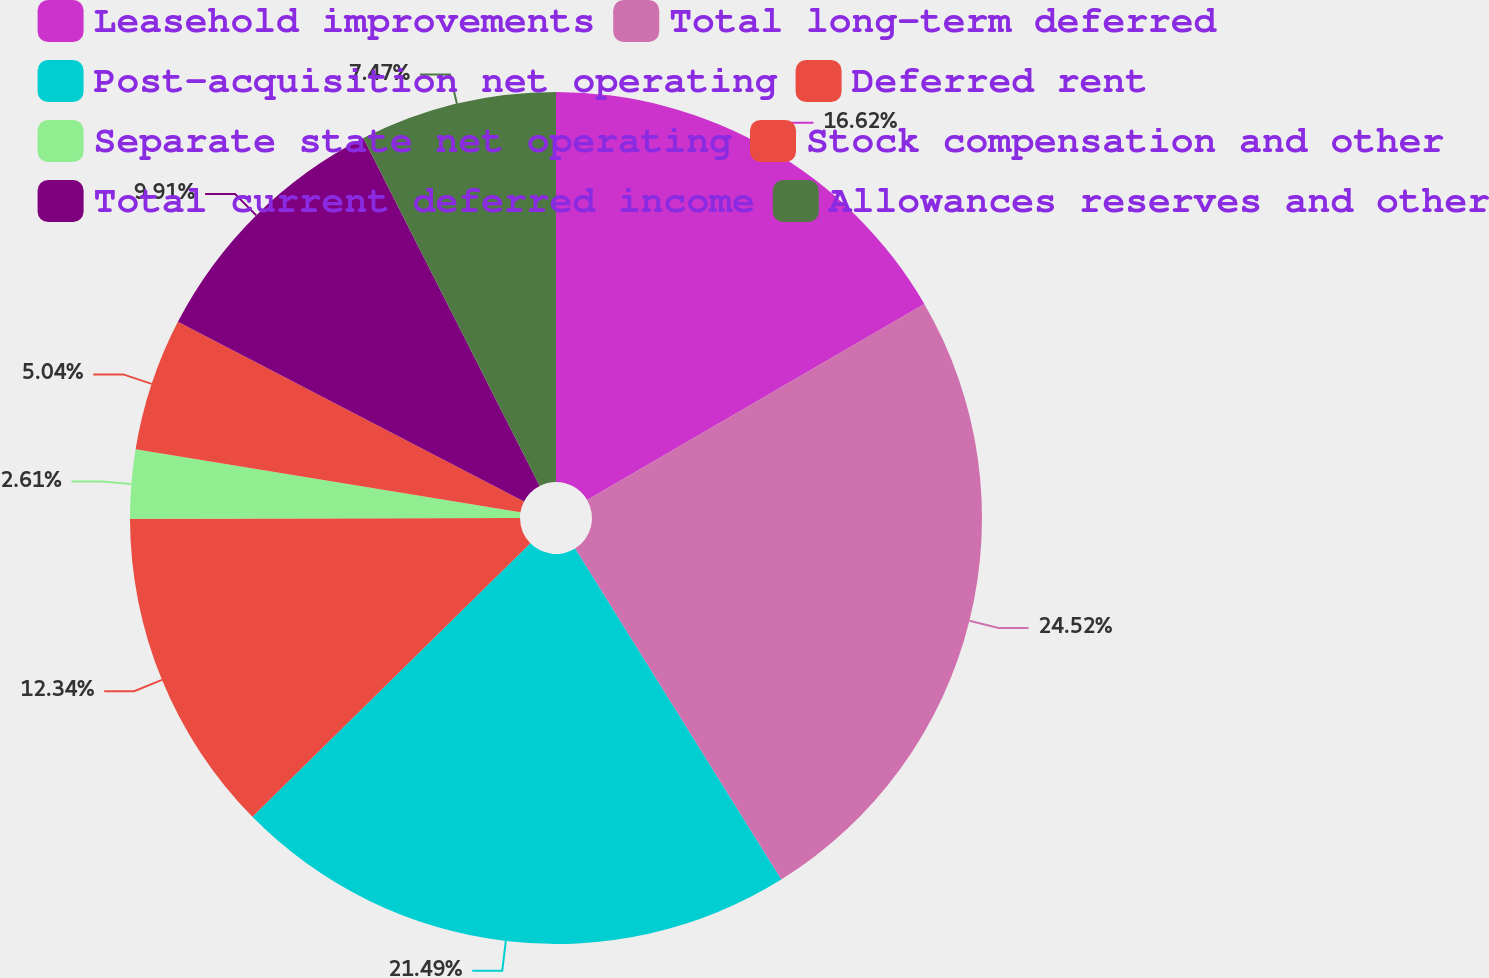Convert chart. <chart><loc_0><loc_0><loc_500><loc_500><pie_chart><fcel>Leasehold improvements<fcel>Total long-term deferred<fcel>Post-acquisition net operating<fcel>Deferred rent<fcel>Separate state net operating<fcel>Stock compensation and other<fcel>Total current deferred income<fcel>Allowances reserves and other<nl><fcel>16.62%<fcel>24.51%<fcel>21.49%<fcel>12.34%<fcel>2.61%<fcel>5.04%<fcel>9.91%<fcel>7.47%<nl></chart> 